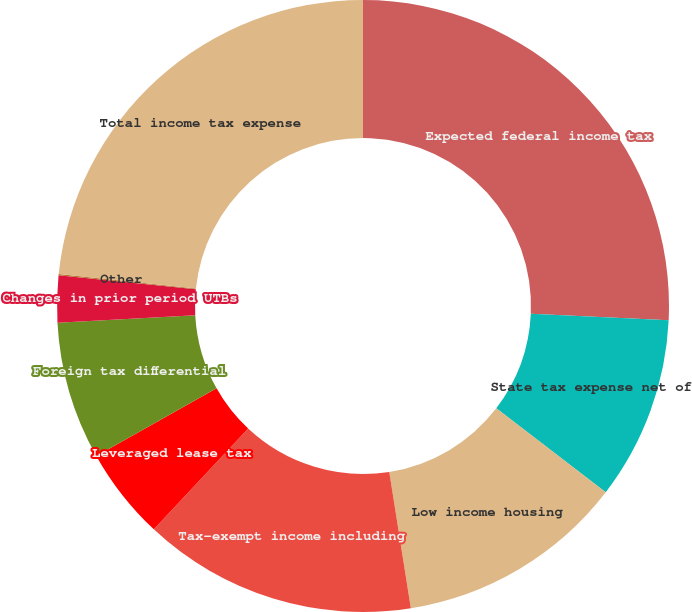<chart> <loc_0><loc_0><loc_500><loc_500><pie_chart><fcel>Expected federal income tax<fcel>State tax expense net of<fcel>Low income housing<fcel>Tax-exempt income including<fcel>Leveraged lease tax<fcel>Foreign tax differential<fcel>Changes in prior period UTBs<fcel>Other<fcel>Total income tax expense<nl><fcel>25.74%<fcel>9.68%<fcel>12.08%<fcel>14.48%<fcel>4.87%<fcel>7.28%<fcel>2.47%<fcel>0.07%<fcel>23.33%<nl></chart> 